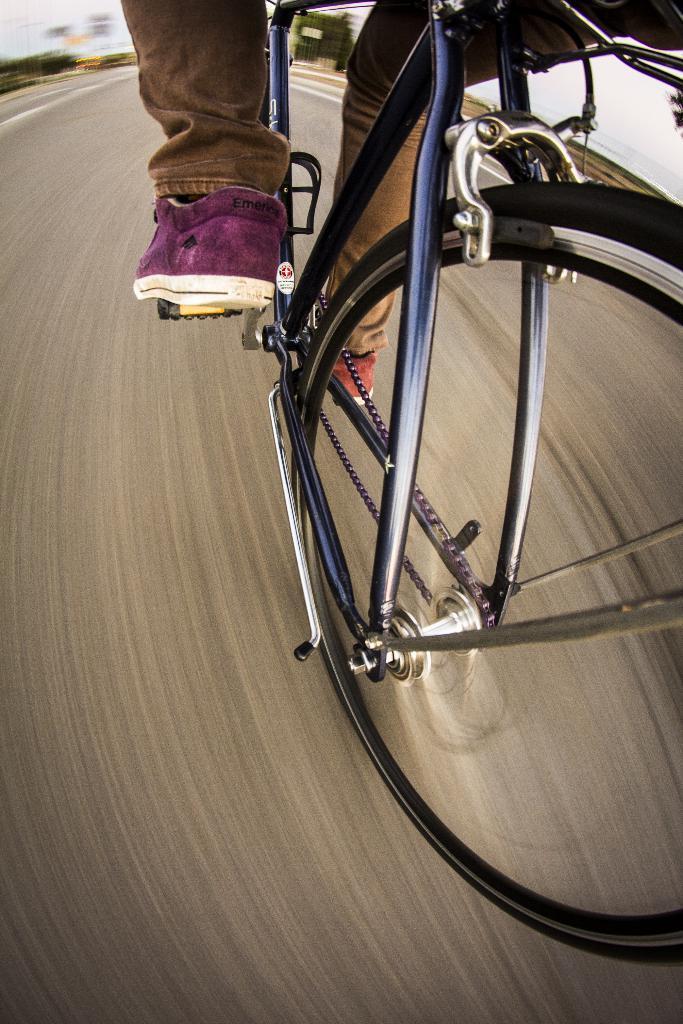Please provide a concise description of this image. The picture consists of a person cycling. In the background is blurred. In the foreground it is road. 